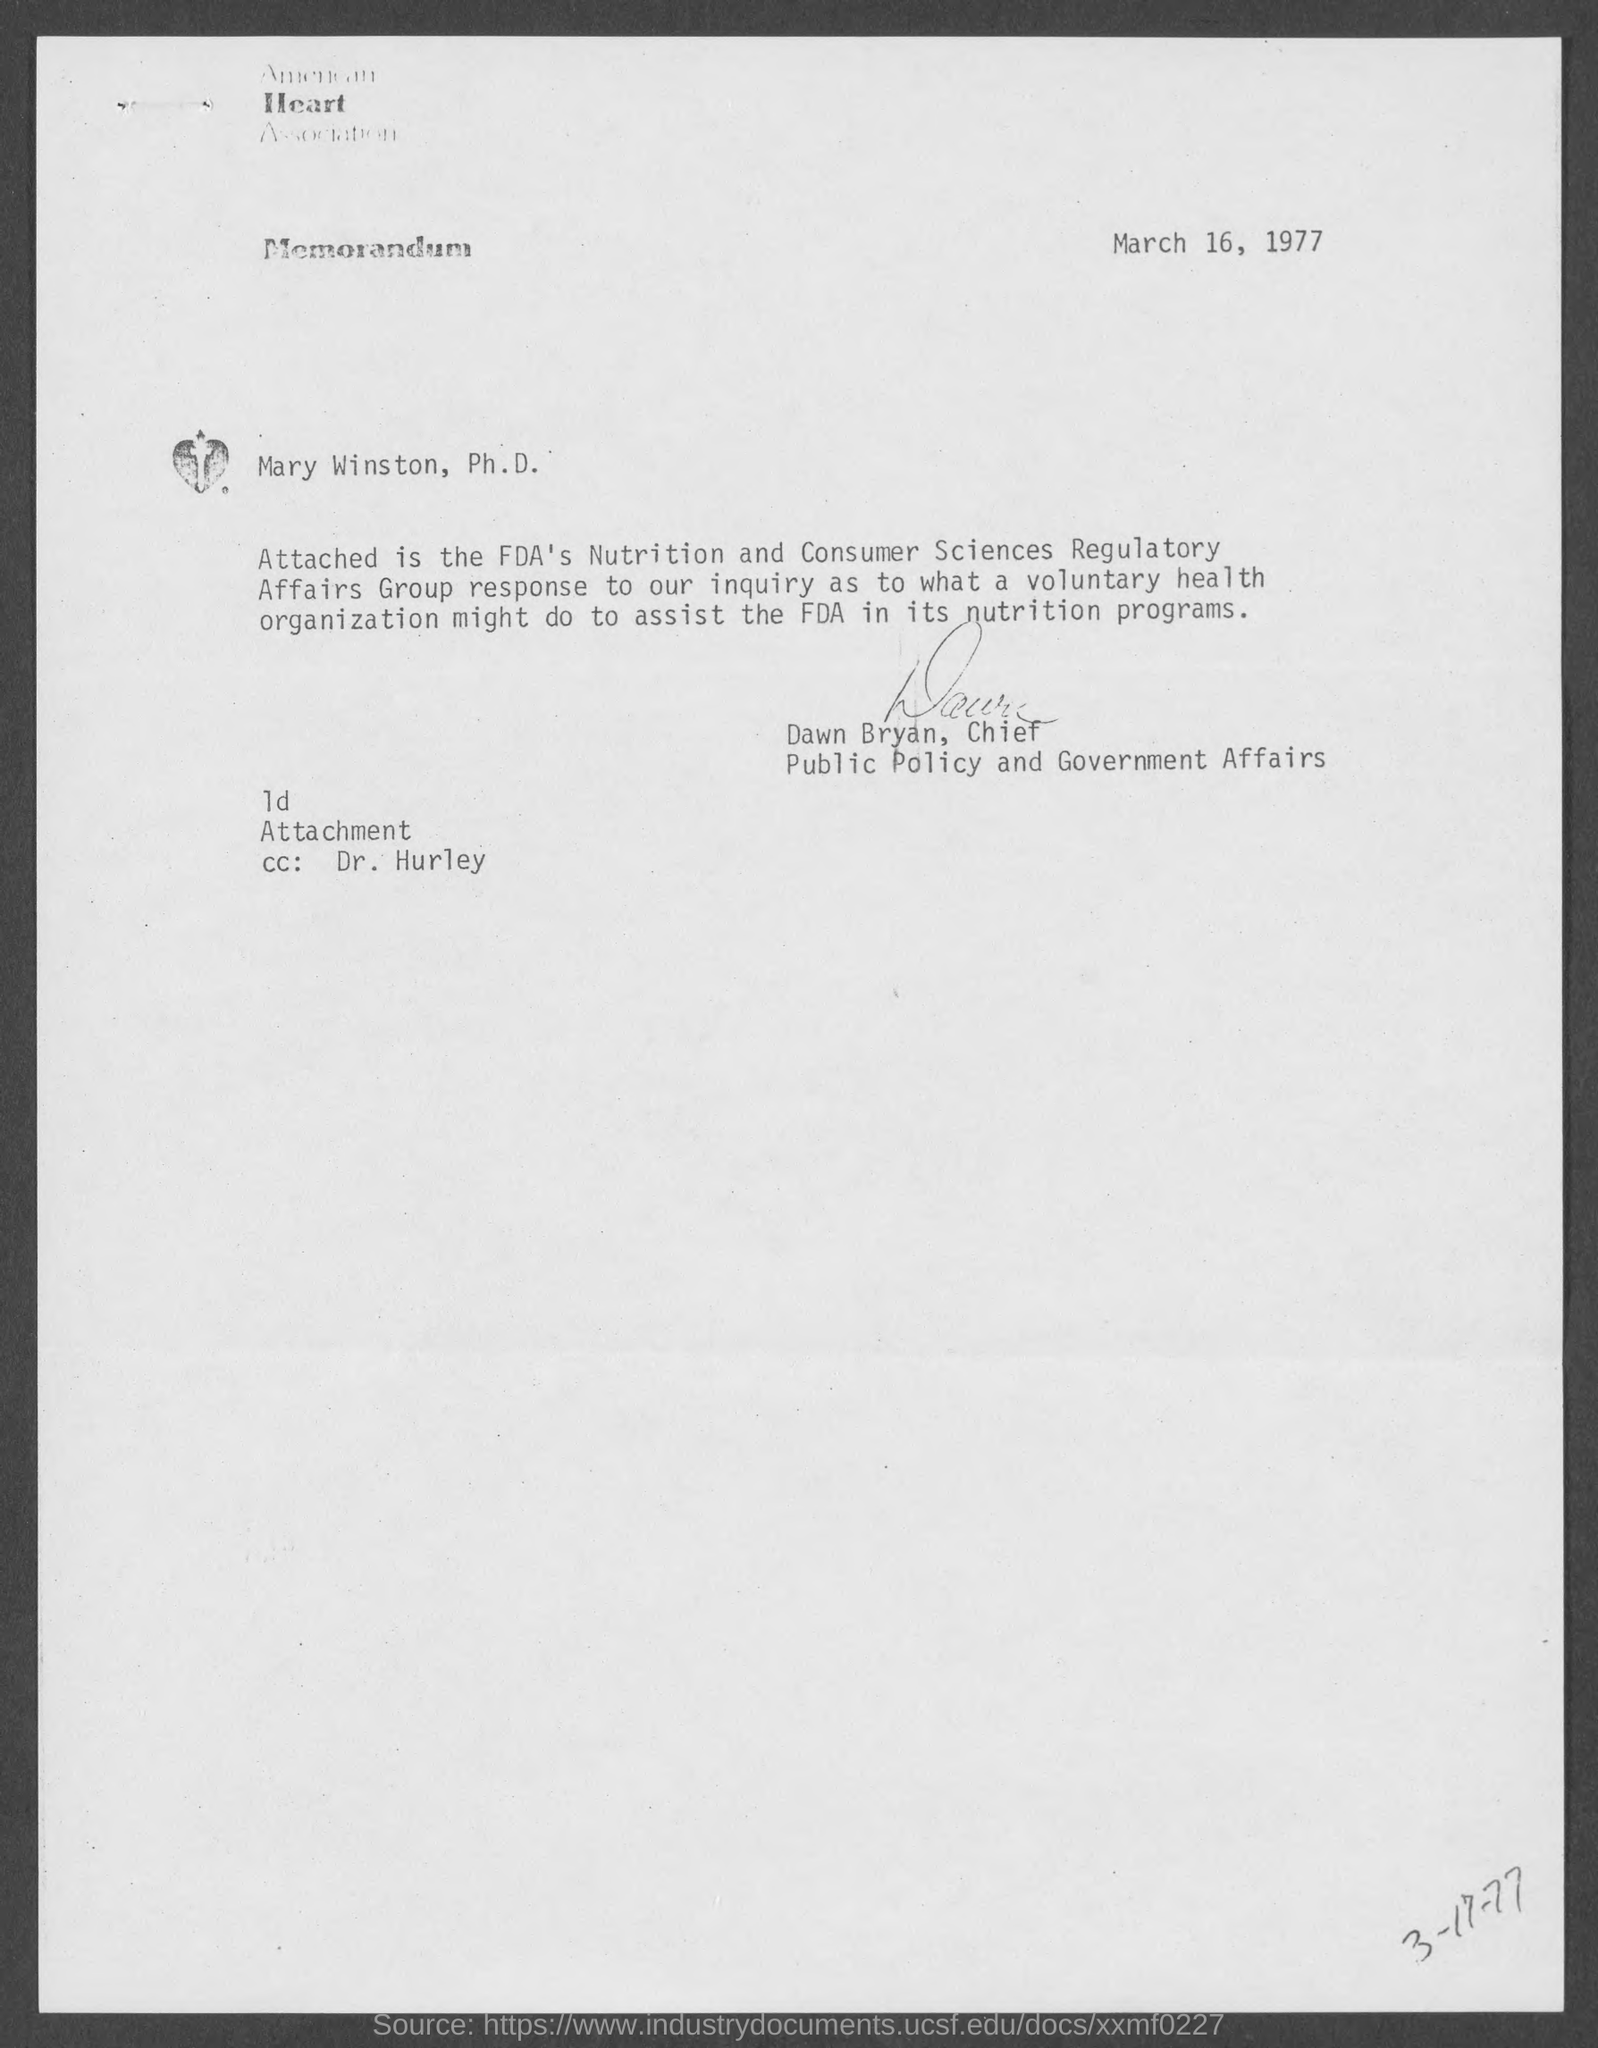What is the name of the heart association at top of the page ?
Your answer should be compact. American Heart Association. When is the memorandum dated?
Make the answer very short. March 16, 1977. Who is the chief, public policy and government affairs ?
Provide a short and direct response. Dawn Bryan. 